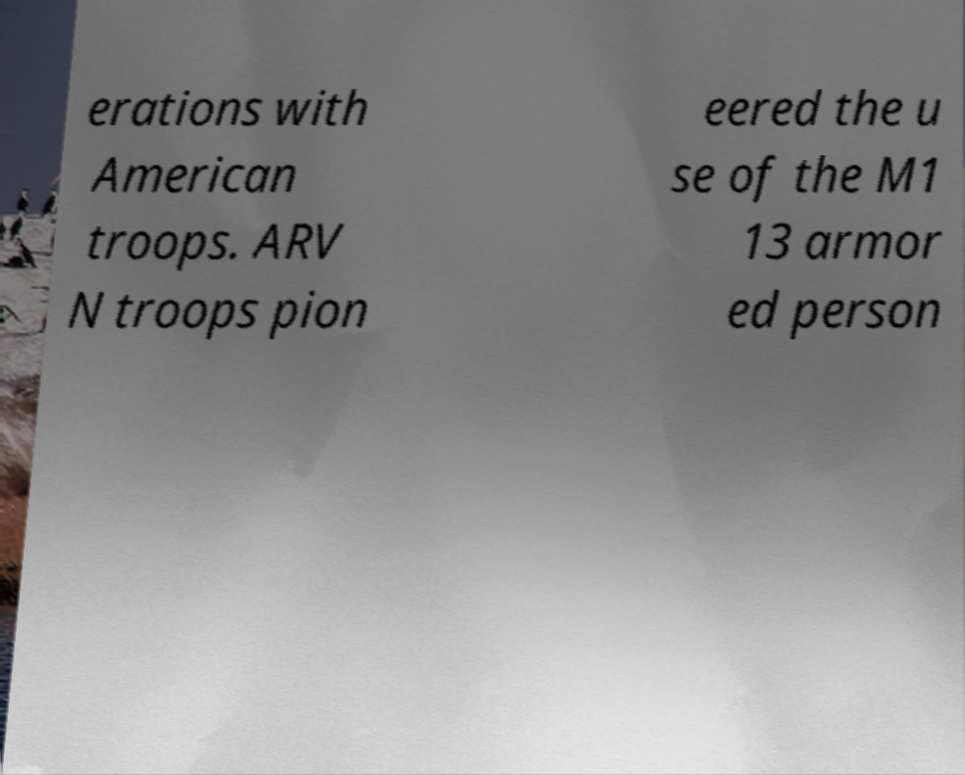Can you accurately transcribe the text from the provided image for me? erations with American troops. ARV N troops pion eered the u se of the M1 13 armor ed person 